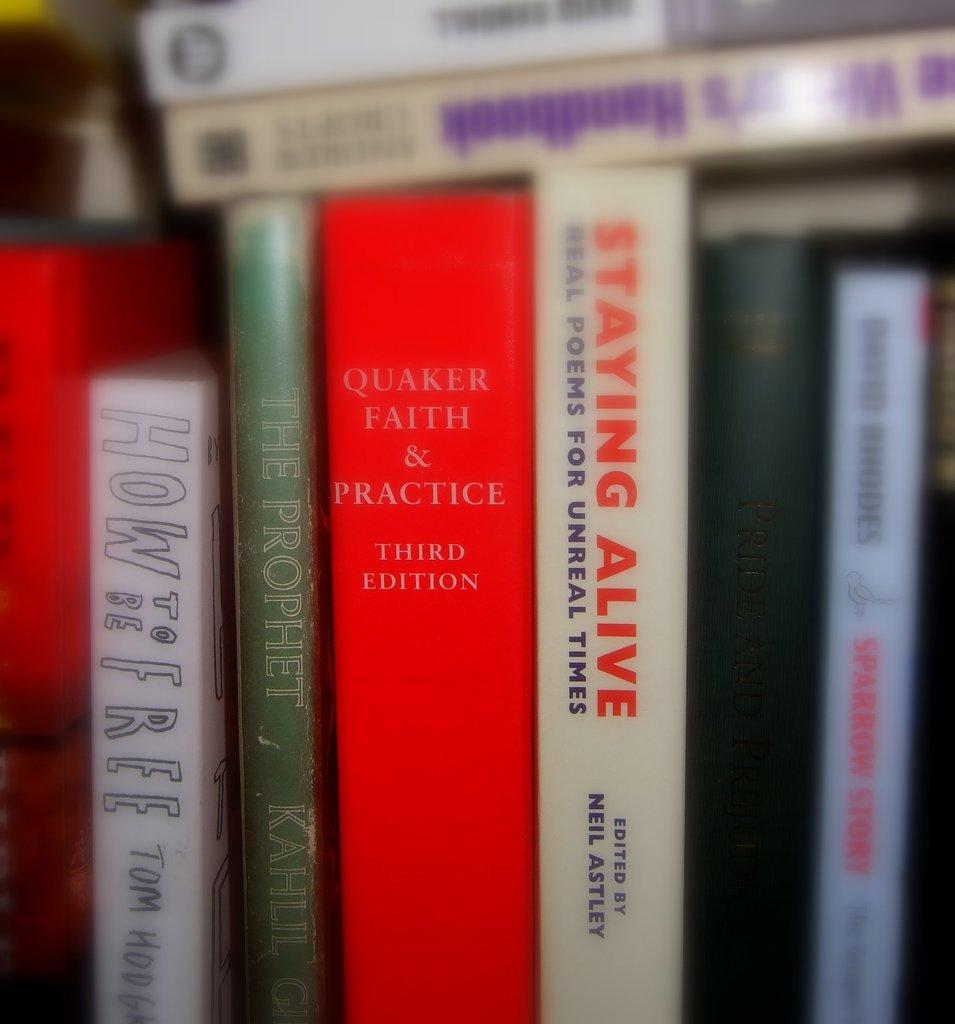<image>
Share a concise interpretation of the image provided. A display of books sits on a shelf with a red book titled Quaker Faith & Practice in the middle 